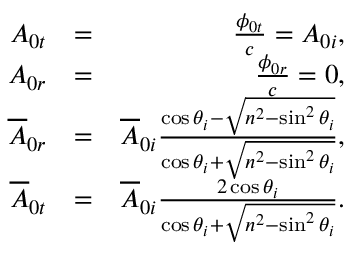<formula> <loc_0><loc_0><loc_500><loc_500>\begin{array} { r l r } { A _ { 0 t } } & { = } & { \frac { \phi _ { 0 t } } { c } = A _ { 0 i } , } \\ { A _ { 0 r } } & { = } & { \frac { \phi _ { 0 r } } { c } = 0 , } \\ { \overline { A } _ { 0 r } } & { = } & { \overline { A } _ { 0 i } \frac { \cos \theta _ { i } - \sqrt { n ^ { 2 } - \sin ^ { 2 } \theta _ { i } } } { \cos \theta _ { i } + \sqrt { n ^ { 2 } - \sin ^ { 2 } \theta _ { i } } } , } \\ { \overline { A } _ { 0 t } } & { = } & { \overline { A } _ { 0 i } \frac { 2 \cos \theta _ { i } } { \cos \theta _ { i } + \sqrt { n ^ { 2 } - \sin ^ { 2 } \theta _ { i } } } . } \end{array}</formula> 